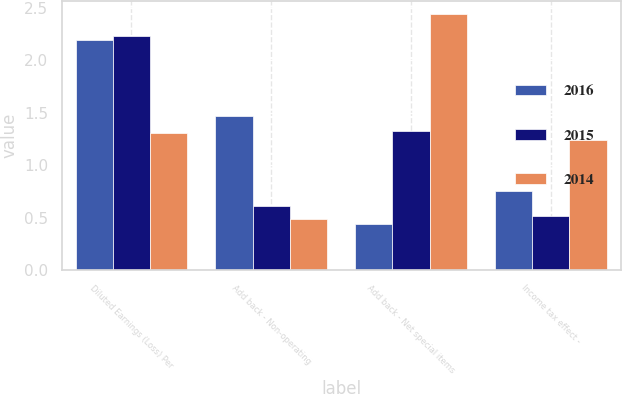Convert chart to OTSL. <chart><loc_0><loc_0><loc_500><loc_500><stacked_bar_chart><ecel><fcel>Diluted Earnings (Loss) Per<fcel>Add back - Non-operating<fcel>Add back - Net special items<fcel>Income tax effect -<nl><fcel>2016<fcel>2.19<fcel>1.47<fcel>0.44<fcel>0.75<nl><fcel>2015<fcel>2.23<fcel>0.61<fcel>1.33<fcel>0.52<nl><fcel>2014<fcel>1.31<fcel>0.49<fcel>2.44<fcel>1.24<nl></chart> 